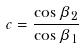Convert formula to latex. <formula><loc_0><loc_0><loc_500><loc_500>c = \frac { \cos \beta _ { 2 } } { \cos \beta _ { 1 } }</formula> 